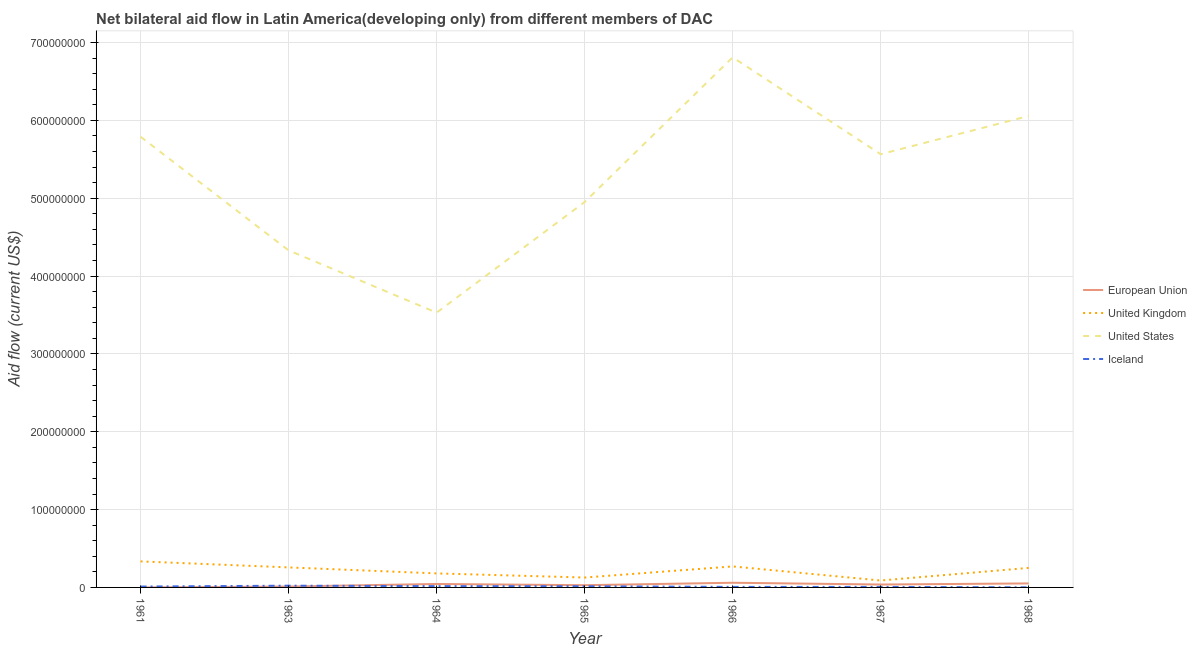How many different coloured lines are there?
Provide a short and direct response. 4. Is the number of lines equal to the number of legend labels?
Provide a short and direct response. Yes. What is the amount of aid given by us in 1965?
Provide a short and direct response. 4.95e+08. Across all years, what is the maximum amount of aid given by us?
Offer a terse response. 6.81e+08. Across all years, what is the minimum amount of aid given by uk?
Your answer should be very brief. 8.89e+06. In which year was the amount of aid given by us maximum?
Give a very brief answer. 1966. In which year was the amount of aid given by us minimum?
Provide a short and direct response. 1964. What is the total amount of aid given by iceland in the graph?
Your response must be concise. 8.05e+06. What is the difference between the amount of aid given by us in 1965 and that in 1968?
Offer a terse response. -1.11e+08. What is the difference between the amount of aid given by us in 1967 and the amount of aid given by eu in 1963?
Keep it short and to the point. 5.55e+08. What is the average amount of aid given by iceland per year?
Ensure brevity in your answer.  1.15e+06. In the year 1967, what is the difference between the amount of aid given by us and amount of aid given by uk?
Offer a terse response. 5.48e+08. In how many years, is the amount of aid given by iceland greater than 400000000 US$?
Your response must be concise. 0. What is the ratio of the amount of aid given by iceland in 1966 to that in 1967?
Offer a terse response. 1.03. Is the amount of aid given by eu in 1964 less than that in 1966?
Give a very brief answer. Yes. Is the difference between the amount of aid given by us in 1964 and 1966 greater than the difference between the amount of aid given by uk in 1964 and 1966?
Keep it short and to the point. No. What is the difference between the highest and the second highest amount of aid given by uk?
Keep it short and to the point. 6.46e+06. What is the difference between the highest and the lowest amount of aid given by us?
Keep it short and to the point. 3.28e+08. Is it the case that in every year, the sum of the amount of aid given by us and amount of aid given by eu is greater than the sum of amount of aid given by uk and amount of aid given by iceland?
Your answer should be compact. Yes. Does the amount of aid given by us monotonically increase over the years?
Keep it short and to the point. No. Is the amount of aid given by uk strictly greater than the amount of aid given by iceland over the years?
Provide a succinct answer. Yes. How many lines are there?
Your response must be concise. 4. What is the difference between two consecutive major ticks on the Y-axis?
Ensure brevity in your answer.  1.00e+08. Does the graph contain any zero values?
Your response must be concise. No. Does the graph contain grids?
Ensure brevity in your answer.  Yes. How many legend labels are there?
Offer a terse response. 4. What is the title of the graph?
Keep it short and to the point. Net bilateral aid flow in Latin America(developing only) from different members of DAC. What is the label or title of the Y-axis?
Your answer should be compact. Aid flow (current US$). What is the Aid flow (current US$) in European Union in 1961?
Offer a very short reply. 10000. What is the Aid flow (current US$) in United Kingdom in 1961?
Your answer should be compact. 3.34e+07. What is the Aid flow (current US$) in United States in 1961?
Your response must be concise. 5.79e+08. What is the Aid flow (current US$) of Iceland in 1961?
Your answer should be compact. 1.13e+06. What is the Aid flow (current US$) of European Union in 1963?
Provide a succinct answer. 1.14e+06. What is the Aid flow (current US$) in United Kingdom in 1963?
Your answer should be compact. 2.57e+07. What is the Aid flow (current US$) of United States in 1963?
Offer a very short reply. 4.33e+08. What is the Aid flow (current US$) in Iceland in 1963?
Keep it short and to the point. 2.23e+06. What is the Aid flow (current US$) of European Union in 1964?
Keep it short and to the point. 4.45e+06. What is the Aid flow (current US$) in United Kingdom in 1964?
Your answer should be compact. 1.80e+07. What is the Aid flow (current US$) in United States in 1964?
Your answer should be very brief. 3.53e+08. What is the Aid flow (current US$) of Iceland in 1964?
Offer a very short reply. 1.67e+06. What is the Aid flow (current US$) in European Union in 1965?
Your response must be concise. 2.85e+06. What is the Aid flow (current US$) of United Kingdom in 1965?
Your response must be concise. 1.27e+07. What is the Aid flow (current US$) of United States in 1965?
Your response must be concise. 4.95e+08. What is the Aid flow (current US$) in Iceland in 1965?
Provide a succinct answer. 1.53e+06. What is the Aid flow (current US$) of European Union in 1966?
Give a very brief answer. 6.01e+06. What is the Aid flow (current US$) in United Kingdom in 1966?
Provide a short and direct response. 2.70e+07. What is the Aid flow (current US$) in United States in 1966?
Make the answer very short. 6.81e+08. What is the Aid flow (current US$) in Iceland in 1966?
Give a very brief answer. 6.80e+05. What is the Aid flow (current US$) of European Union in 1967?
Provide a short and direct response. 3.73e+06. What is the Aid flow (current US$) of United Kingdom in 1967?
Ensure brevity in your answer.  8.89e+06. What is the Aid flow (current US$) in United States in 1967?
Provide a succinct answer. 5.57e+08. What is the Aid flow (current US$) in Iceland in 1967?
Your answer should be very brief. 6.60e+05. What is the Aid flow (current US$) in European Union in 1968?
Your answer should be compact. 5.15e+06. What is the Aid flow (current US$) in United Kingdom in 1968?
Give a very brief answer. 2.51e+07. What is the Aid flow (current US$) in United States in 1968?
Provide a short and direct response. 6.06e+08. Across all years, what is the maximum Aid flow (current US$) of European Union?
Keep it short and to the point. 6.01e+06. Across all years, what is the maximum Aid flow (current US$) in United Kingdom?
Offer a very short reply. 3.34e+07. Across all years, what is the maximum Aid flow (current US$) in United States?
Keep it short and to the point. 6.81e+08. Across all years, what is the maximum Aid flow (current US$) in Iceland?
Provide a short and direct response. 2.23e+06. Across all years, what is the minimum Aid flow (current US$) of European Union?
Make the answer very short. 10000. Across all years, what is the minimum Aid flow (current US$) in United Kingdom?
Make the answer very short. 8.89e+06. Across all years, what is the minimum Aid flow (current US$) of United States?
Keep it short and to the point. 3.53e+08. What is the total Aid flow (current US$) of European Union in the graph?
Your response must be concise. 2.33e+07. What is the total Aid flow (current US$) of United Kingdom in the graph?
Ensure brevity in your answer.  1.51e+08. What is the total Aid flow (current US$) of United States in the graph?
Your response must be concise. 3.70e+09. What is the total Aid flow (current US$) in Iceland in the graph?
Your answer should be very brief. 8.05e+06. What is the difference between the Aid flow (current US$) of European Union in 1961 and that in 1963?
Give a very brief answer. -1.13e+06. What is the difference between the Aid flow (current US$) of United Kingdom in 1961 and that in 1963?
Make the answer very short. 7.73e+06. What is the difference between the Aid flow (current US$) in United States in 1961 and that in 1963?
Provide a succinct answer. 1.46e+08. What is the difference between the Aid flow (current US$) in Iceland in 1961 and that in 1963?
Your response must be concise. -1.10e+06. What is the difference between the Aid flow (current US$) in European Union in 1961 and that in 1964?
Make the answer very short. -4.44e+06. What is the difference between the Aid flow (current US$) of United Kingdom in 1961 and that in 1964?
Your response must be concise. 1.54e+07. What is the difference between the Aid flow (current US$) in United States in 1961 and that in 1964?
Offer a terse response. 2.26e+08. What is the difference between the Aid flow (current US$) of Iceland in 1961 and that in 1964?
Offer a very short reply. -5.40e+05. What is the difference between the Aid flow (current US$) in European Union in 1961 and that in 1965?
Make the answer very short. -2.84e+06. What is the difference between the Aid flow (current US$) in United Kingdom in 1961 and that in 1965?
Provide a short and direct response. 2.07e+07. What is the difference between the Aid flow (current US$) in United States in 1961 and that in 1965?
Provide a succinct answer. 8.39e+07. What is the difference between the Aid flow (current US$) in Iceland in 1961 and that in 1965?
Ensure brevity in your answer.  -4.00e+05. What is the difference between the Aid flow (current US$) in European Union in 1961 and that in 1966?
Your answer should be compact. -6.00e+06. What is the difference between the Aid flow (current US$) in United Kingdom in 1961 and that in 1966?
Make the answer very short. 6.46e+06. What is the difference between the Aid flow (current US$) in United States in 1961 and that in 1966?
Your answer should be compact. -1.02e+08. What is the difference between the Aid flow (current US$) in Iceland in 1961 and that in 1966?
Give a very brief answer. 4.50e+05. What is the difference between the Aid flow (current US$) of European Union in 1961 and that in 1967?
Your answer should be compact. -3.72e+06. What is the difference between the Aid flow (current US$) of United Kingdom in 1961 and that in 1967?
Your response must be concise. 2.46e+07. What is the difference between the Aid flow (current US$) of United States in 1961 and that in 1967?
Your answer should be very brief. 2.25e+07. What is the difference between the Aid flow (current US$) of European Union in 1961 and that in 1968?
Offer a terse response. -5.14e+06. What is the difference between the Aid flow (current US$) in United Kingdom in 1961 and that in 1968?
Provide a short and direct response. 8.36e+06. What is the difference between the Aid flow (current US$) in United States in 1961 and that in 1968?
Make the answer very short. -2.67e+07. What is the difference between the Aid flow (current US$) of Iceland in 1961 and that in 1968?
Offer a terse response. 9.80e+05. What is the difference between the Aid flow (current US$) of European Union in 1963 and that in 1964?
Keep it short and to the point. -3.31e+06. What is the difference between the Aid flow (current US$) in United Kingdom in 1963 and that in 1964?
Your answer should be very brief. 7.70e+06. What is the difference between the Aid flow (current US$) of United States in 1963 and that in 1964?
Your response must be concise. 8.00e+07. What is the difference between the Aid flow (current US$) in Iceland in 1963 and that in 1964?
Keep it short and to the point. 5.60e+05. What is the difference between the Aid flow (current US$) in European Union in 1963 and that in 1965?
Provide a succinct answer. -1.71e+06. What is the difference between the Aid flow (current US$) in United Kingdom in 1963 and that in 1965?
Give a very brief answer. 1.30e+07. What is the difference between the Aid flow (current US$) of United States in 1963 and that in 1965?
Offer a very short reply. -6.21e+07. What is the difference between the Aid flow (current US$) in Iceland in 1963 and that in 1965?
Your response must be concise. 7.00e+05. What is the difference between the Aid flow (current US$) in European Union in 1963 and that in 1966?
Your answer should be very brief. -4.87e+06. What is the difference between the Aid flow (current US$) in United Kingdom in 1963 and that in 1966?
Offer a very short reply. -1.27e+06. What is the difference between the Aid flow (current US$) in United States in 1963 and that in 1966?
Make the answer very short. -2.48e+08. What is the difference between the Aid flow (current US$) in Iceland in 1963 and that in 1966?
Your answer should be compact. 1.55e+06. What is the difference between the Aid flow (current US$) of European Union in 1963 and that in 1967?
Keep it short and to the point. -2.59e+06. What is the difference between the Aid flow (current US$) in United Kingdom in 1963 and that in 1967?
Provide a succinct answer. 1.68e+07. What is the difference between the Aid flow (current US$) in United States in 1963 and that in 1967?
Your answer should be compact. -1.24e+08. What is the difference between the Aid flow (current US$) in Iceland in 1963 and that in 1967?
Your answer should be compact. 1.57e+06. What is the difference between the Aid flow (current US$) in European Union in 1963 and that in 1968?
Provide a succinct answer. -4.01e+06. What is the difference between the Aid flow (current US$) of United Kingdom in 1963 and that in 1968?
Offer a very short reply. 6.30e+05. What is the difference between the Aid flow (current US$) in United States in 1963 and that in 1968?
Ensure brevity in your answer.  -1.73e+08. What is the difference between the Aid flow (current US$) in Iceland in 1963 and that in 1968?
Your answer should be compact. 2.08e+06. What is the difference between the Aid flow (current US$) in European Union in 1964 and that in 1965?
Give a very brief answer. 1.60e+06. What is the difference between the Aid flow (current US$) in United Kingdom in 1964 and that in 1965?
Provide a short and direct response. 5.31e+06. What is the difference between the Aid flow (current US$) of United States in 1964 and that in 1965?
Provide a short and direct response. -1.42e+08. What is the difference between the Aid flow (current US$) of Iceland in 1964 and that in 1965?
Your response must be concise. 1.40e+05. What is the difference between the Aid flow (current US$) of European Union in 1964 and that in 1966?
Your response must be concise. -1.56e+06. What is the difference between the Aid flow (current US$) in United Kingdom in 1964 and that in 1966?
Keep it short and to the point. -8.97e+06. What is the difference between the Aid flow (current US$) in United States in 1964 and that in 1966?
Make the answer very short. -3.28e+08. What is the difference between the Aid flow (current US$) of Iceland in 1964 and that in 1966?
Your answer should be compact. 9.90e+05. What is the difference between the Aid flow (current US$) in European Union in 1964 and that in 1967?
Make the answer very short. 7.20e+05. What is the difference between the Aid flow (current US$) in United Kingdom in 1964 and that in 1967?
Provide a succinct answer. 9.13e+06. What is the difference between the Aid flow (current US$) in United States in 1964 and that in 1967?
Your answer should be compact. -2.04e+08. What is the difference between the Aid flow (current US$) in Iceland in 1964 and that in 1967?
Provide a succinct answer. 1.01e+06. What is the difference between the Aid flow (current US$) in European Union in 1964 and that in 1968?
Make the answer very short. -7.00e+05. What is the difference between the Aid flow (current US$) of United Kingdom in 1964 and that in 1968?
Your answer should be compact. -7.07e+06. What is the difference between the Aid flow (current US$) of United States in 1964 and that in 1968?
Your answer should be compact. -2.53e+08. What is the difference between the Aid flow (current US$) of Iceland in 1964 and that in 1968?
Provide a short and direct response. 1.52e+06. What is the difference between the Aid flow (current US$) of European Union in 1965 and that in 1966?
Ensure brevity in your answer.  -3.16e+06. What is the difference between the Aid flow (current US$) in United Kingdom in 1965 and that in 1966?
Offer a very short reply. -1.43e+07. What is the difference between the Aid flow (current US$) in United States in 1965 and that in 1966?
Offer a terse response. -1.86e+08. What is the difference between the Aid flow (current US$) in Iceland in 1965 and that in 1966?
Provide a short and direct response. 8.50e+05. What is the difference between the Aid flow (current US$) in European Union in 1965 and that in 1967?
Ensure brevity in your answer.  -8.80e+05. What is the difference between the Aid flow (current US$) of United Kingdom in 1965 and that in 1967?
Your answer should be very brief. 3.82e+06. What is the difference between the Aid flow (current US$) of United States in 1965 and that in 1967?
Offer a terse response. -6.14e+07. What is the difference between the Aid flow (current US$) in Iceland in 1965 and that in 1967?
Make the answer very short. 8.70e+05. What is the difference between the Aid flow (current US$) of European Union in 1965 and that in 1968?
Provide a short and direct response. -2.30e+06. What is the difference between the Aid flow (current US$) of United Kingdom in 1965 and that in 1968?
Your answer should be compact. -1.24e+07. What is the difference between the Aid flow (current US$) of United States in 1965 and that in 1968?
Make the answer very short. -1.11e+08. What is the difference between the Aid flow (current US$) in Iceland in 1965 and that in 1968?
Make the answer very short. 1.38e+06. What is the difference between the Aid flow (current US$) of European Union in 1966 and that in 1967?
Provide a short and direct response. 2.28e+06. What is the difference between the Aid flow (current US$) in United Kingdom in 1966 and that in 1967?
Keep it short and to the point. 1.81e+07. What is the difference between the Aid flow (current US$) in United States in 1966 and that in 1967?
Provide a short and direct response. 1.24e+08. What is the difference between the Aid flow (current US$) of European Union in 1966 and that in 1968?
Your answer should be compact. 8.60e+05. What is the difference between the Aid flow (current US$) in United Kingdom in 1966 and that in 1968?
Your response must be concise. 1.90e+06. What is the difference between the Aid flow (current US$) in United States in 1966 and that in 1968?
Offer a very short reply. 7.53e+07. What is the difference between the Aid flow (current US$) in Iceland in 1966 and that in 1968?
Make the answer very short. 5.30e+05. What is the difference between the Aid flow (current US$) of European Union in 1967 and that in 1968?
Give a very brief answer. -1.42e+06. What is the difference between the Aid flow (current US$) of United Kingdom in 1967 and that in 1968?
Give a very brief answer. -1.62e+07. What is the difference between the Aid flow (current US$) in United States in 1967 and that in 1968?
Make the answer very short. -4.92e+07. What is the difference between the Aid flow (current US$) in Iceland in 1967 and that in 1968?
Your response must be concise. 5.10e+05. What is the difference between the Aid flow (current US$) of European Union in 1961 and the Aid flow (current US$) of United Kingdom in 1963?
Your answer should be very brief. -2.57e+07. What is the difference between the Aid flow (current US$) of European Union in 1961 and the Aid flow (current US$) of United States in 1963?
Offer a terse response. -4.33e+08. What is the difference between the Aid flow (current US$) in European Union in 1961 and the Aid flow (current US$) in Iceland in 1963?
Give a very brief answer. -2.22e+06. What is the difference between the Aid flow (current US$) of United Kingdom in 1961 and the Aid flow (current US$) of United States in 1963?
Your answer should be very brief. -4.00e+08. What is the difference between the Aid flow (current US$) in United Kingdom in 1961 and the Aid flow (current US$) in Iceland in 1963?
Offer a terse response. 3.12e+07. What is the difference between the Aid flow (current US$) of United States in 1961 and the Aid flow (current US$) of Iceland in 1963?
Your answer should be very brief. 5.77e+08. What is the difference between the Aid flow (current US$) in European Union in 1961 and the Aid flow (current US$) in United Kingdom in 1964?
Your answer should be compact. -1.80e+07. What is the difference between the Aid flow (current US$) of European Union in 1961 and the Aid flow (current US$) of United States in 1964?
Make the answer very short. -3.53e+08. What is the difference between the Aid flow (current US$) of European Union in 1961 and the Aid flow (current US$) of Iceland in 1964?
Ensure brevity in your answer.  -1.66e+06. What is the difference between the Aid flow (current US$) in United Kingdom in 1961 and the Aid flow (current US$) in United States in 1964?
Give a very brief answer. -3.20e+08. What is the difference between the Aid flow (current US$) of United Kingdom in 1961 and the Aid flow (current US$) of Iceland in 1964?
Provide a short and direct response. 3.18e+07. What is the difference between the Aid flow (current US$) of United States in 1961 and the Aid flow (current US$) of Iceland in 1964?
Give a very brief answer. 5.77e+08. What is the difference between the Aid flow (current US$) in European Union in 1961 and the Aid flow (current US$) in United Kingdom in 1965?
Offer a very short reply. -1.27e+07. What is the difference between the Aid flow (current US$) of European Union in 1961 and the Aid flow (current US$) of United States in 1965?
Provide a succinct answer. -4.95e+08. What is the difference between the Aid flow (current US$) of European Union in 1961 and the Aid flow (current US$) of Iceland in 1965?
Make the answer very short. -1.52e+06. What is the difference between the Aid flow (current US$) in United Kingdom in 1961 and the Aid flow (current US$) in United States in 1965?
Provide a succinct answer. -4.62e+08. What is the difference between the Aid flow (current US$) of United Kingdom in 1961 and the Aid flow (current US$) of Iceland in 1965?
Provide a short and direct response. 3.19e+07. What is the difference between the Aid flow (current US$) in United States in 1961 and the Aid flow (current US$) in Iceland in 1965?
Give a very brief answer. 5.77e+08. What is the difference between the Aid flow (current US$) in European Union in 1961 and the Aid flow (current US$) in United Kingdom in 1966?
Your answer should be very brief. -2.70e+07. What is the difference between the Aid flow (current US$) in European Union in 1961 and the Aid flow (current US$) in United States in 1966?
Provide a short and direct response. -6.81e+08. What is the difference between the Aid flow (current US$) in European Union in 1961 and the Aid flow (current US$) in Iceland in 1966?
Your response must be concise. -6.70e+05. What is the difference between the Aid flow (current US$) in United Kingdom in 1961 and the Aid flow (current US$) in United States in 1966?
Keep it short and to the point. -6.48e+08. What is the difference between the Aid flow (current US$) in United Kingdom in 1961 and the Aid flow (current US$) in Iceland in 1966?
Offer a very short reply. 3.28e+07. What is the difference between the Aid flow (current US$) of United States in 1961 and the Aid flow (current US$) of Iceland in 1966?
Make the answer very short. 5.78e+08. What is the difference between the Aid flow (current US$) in European Union in 1961 and the Aid flow (current US$) in United Kingdom in 1967?
Provide a short and direct response. -8.88e+06. What is the difference between the Aid flow (current US$) in European Union in 1961 and the Aid flow (current US$) in United States in 1967?
Offer a very short reply. -5.57e+08. What is the difference between the Aid flow (current US$) of European Union in 1961 and the Aid flow (current US$) of Iceland in 1967?
Provide a succinct answer. -6.50e+05. What is the difference between the Aid flow (current US$) of United Kingdom in 1961 and the Aid flow (current US$) of United States in 1967?
Your response must be concise. -5.23e+08. What is the difference between the Aid flow (current US$) in United Kingdom in 1961 and the Aid flow (current US$) in Iceland in 1967?
Offer a very short reply. 3.28e+07. What is the difference between the Aid flow (current US$) in United States in 1961 and the Aid flow (current US$) in Iceland in 1967?
Provide a short and direct response. 5.78e+08. What is the difference between the Aid flow (current US$) of European Union in 1961 and the Aid flow (current US$) of United Kingdom in 1968?
Provide a succinct answer. -2.51e+07. What is the difference between the Aid flow (current US$) in European Union in 1961 and the Aid flow (current US$) in United States in 1968?
Offer a terse response. -6.06e+08. What is the difference between the Aid flow (current US$) of European Union in 1961 and the Aid flow (current US$) of Iceland in 1968?
Your answer should be compact. -1.40e+05. What is the difference between the Aid flow (current US$) of United Kingdom in 1961 and the Aid flow (current US$) of United States in 1968?
Keep it short and to the point. -5.72e+08. What is the difference between the Aid flow (current US$) of United Kingdom in 1961 and the Aid flow (current US$) of Iceland in 1968?
Your response must be concise. 3.33e+07. What is the difference between the Aid flow (current US$) of United States in 1961 and the Aid flow (current US$) of Iceland in 1968?
Your answer should be compact. 5.79e+08. What is the difference between the Aid flow (current US$) of European Union in 1963 and the Aid flow (current US$) of United Kingdom in 1964?
Your answer should be very brief. -1.69e+07. What is the difference between the Aid flow (current US$) of European Union in 1963 and the Aid flow (current US$) of United States in 1964?
Your response must be concise. -3.52e+08. What is the difference between the Aid flow (current US$) of European Union in 1963 and the Aid flow (current US$) of Iceland in 1964?
Offer a terse response. -5.30e+05. What is the difference between the Aid flow (current US$) of United Kingdom in 1963 and the Aid flow (current US$) of United States in 1964?
Keep it short and to the point. -3.27e+08. What is the difference between the Aid flow (current US$) of United Kingdom in 1963 and the Aid flow (current US$) of Iceland in 1964?
Provide a succinct answer. 2.40e+07. What is the difference between the Aid flow (current US$) of United States in 1963 and the Aid flow (current US$) of Iceland in 1964?
Ensure brevity in your answer.  4.31e+08. What is the difference between the Aid flow (current US$) of European Union in 1963 and the Aid flow (current US$) of United Kingdom in 1965?
Provide a succinct answer. -1.16e+07. What is the difference between the Aid flow (current US$) in European Union in 1963 and the Aid flow (current US$) in United States in 1965?
Give a very brief answer. -4.94e+08. What is the difference between the Aid flow (current US$) in European Union in 1963 and the Aid flow (current US$) in Iceland in 1965?
Offer a terse response. -3.90e+05. What is the difference between the Aid flow (current US$) in United Kingdom in 1963 and the Aid flow (current US$) in United States in 1965?
Your answer should be compact. -4.69e+08. What is the difference between the Aid flow (current US$) of United Kingdom in 1963 and the Aid flow (current US$) of Iceland in 1965?
Offer a terse response. 2.42e+07. What is the difference between the Aid flow (current US$) of United States in 1963 and the Aid flow (current US$) of Iceland in 1965?
Your response must be concise. 4.31e+08. What is the difference between the Aid flow (current US$) of European Union in 1963 and the Aid flow (current US$) of United Kingdom in 1966?
Provide a short and direct response. -2.58e+07. What is the difference between the Aid flow (current US$) of European Union in 1963 and the Aid flow (current US$) of United States in 1966?
Provide a short and direct response. -6.80e+08. What is the difference between the Aid flow (current US$) of United Kingdom in 1963 and the Aid flow (current US$) of United States in 1966?
Provide a succinct answer. -6.55e+08. What is the difference between the Aid flow (current US$) of United Kingdom in 1963 and the Aid flow (current US$) of Iceland in 1966?
Your answer should be very brief. 2.50e+07. What is the difference between the Aid flow (current US$) of United States in 1963 and the Aid flow (current US$) of Iceland in 1966?
Your answer should be very brief. 4.32e+08. What is the difference between the Aid flow (current US$) of European Union in 1963 and the Aid flow (current US$) of United Kingdom in 1967?
Offer a very short reply. -7.75e+06. What is the difference between the Aid flow (current US$) of European Union in 1963 and the Aid flow (current US$) of United States in 1967?
Make the answer very short. -5.55e+08. What is the difference between the Aid flow (current US$) in European Union in 1963 and the Aid flow (current US$) in Iceland in 1967?
Provide a short and direct response. 4.80e+05. What is the difference between the Aid flow (current US$) in United Kingdom in 1963 and the Aid flow (current US$) in United States in 1967?
Keep it short and to the point. -5.31e+08. What is the difference between the Aid flow (current US$) in United Kingdom in 1963 and the Aid flow (current US$) in Iceland in 1967?
Offer a terse response. 2.51e+07. What is the difference between the Aid flow (current US$) of United States in 1963 and the Aid flow (current US$) of Iceland in 1967?
Your response must be concise. 4.32e+08. What is the difference between the Aid flow (current US$) in European Union in 1963 and the Aid flow (current US$) in United Kingdom in 1968?
Provide a short and direct response. -2.40e+07. What is the difference between the Aid flow (current US$) in European Union in 1963 and the Aid flow (current US$) in United States in 1968?
Your response must be concise. -6.05e+08. What is the difference between the Aid flow (current US$) in European Union in 1963 and the Aid flow (current US$) in Iceland in 1968?
Provide a succinct answer. 9.90e+05. What is the difference between the Aid flow (current US$) in United Kingdom in 1963 and the Aid flow (current US$) in United States in 1968?
Your response must be concise. -5.80e+08. What is the difference between the Aid flow (current US$) in United Kingdom in 1963 and the Aid flow (current US$) in Iceland in 1968?
Make the answer very short. 2.56e+07. What is the difference between the Aid flow (current US$) in United States in 1963 and the Aid flow (current US$) in Iceland in 1968?
Ensure brevity in your answer.  4.33e+08. What is the difference between the Aid flow (current US$) in European Union in 1964 and the Aid flow (current US$) in United Kingdom in 1965?
Ensure brevity in your answer.  -8.26e+06. What is the difference between the Aid flow (current US$) of European Union in 1964 and the Aid flow (current US$) of United States in 1965?
Make the answer very short. -4.91e+08. What is the difference between the Aid flow (current US$) in European Union in 1964 and the Aid flow (current US$) in Iceland in 1965?
Provide a succinct answer. 2.92e+06. What is the difference between the Aid flow (current US$) in United Kingdom in 1964 and the Aid flow (current US$) in United States in 1965?
Your response must be concise. -4.77e+08. What is the difference between the Aid flow (current US$) of United Kingdom in 1964 and the Aid flow (current US$) of Iceland in 1965?
Make the answer very short. 1.65e+07. What is the difference between the Aid flow (current US$) in United States in 1964 and the Aid flow (current US$) in Iceland in 1965?
Ensure brevity in your answer.  3.51e+08. What is the difference between the Aid flow (current US$) in European Union in 1964 and the Aid flow (current US$) in United Kingdom in 1966?
Provide a short and direct response. -2.25e+07. What is the difference between the Aid flow (current US$) in European Union in 1964 and the Aid flow (current US$) in United States in 1966?
Offer a very short reply. -6.77e+08. What is the difference between the Aid flow (current US$) of European Union in 1964 and the Aid flow (current US$) of Iceland in 1966?
Make the answer very short. 3.77e+06. What is the difference between the Aid flow (current US$) in United Kingdom in 1964 and the Aid flow (current US$) in United States in 1966?
Provide a short and direct response. -6.63e+08. What is the difference between the Aid flow (current US$) of United Kingdom in 1964 and the Aid flow (current US$) of Iceland in 1966?
Provide a succinct answer. 1.73e+07. What is the difference between the Aid flow (current US$) of United States in 1964 and the Aid flow (current US$) of Iceland in 1966?
Offer a very short reply. 3.52e+08. What is the difference between the Aid flow (current US$) of European Union in 1964 and the Aid flow (current US$) of United Kingdom in 1967?
Provide a succinct answer. -4.44e+06. What is the difference between the Aid flow (current US$) of European Union in 1964 and the Aid flow (current US$) of United States in 1967?
Your answer should be very brief. -5.52e+08. What is the difference between the Aid flow (current US$) in European Union in 1964 and the Aid flow (current US$) in Iceland in 1967?
Keep it short and to the point. 3.79e+06. What is the difference between the Aid flow (current US$) in United Kingdom in 1964 and the Aid flow (current US$) in United States in 1967?
Make the answer very short. -5.39e+08. What is the difference between the Aid flow (current US$) of United Kingdom in 1964 and the Aid flow (current US$) of Iceland in 1967?
Ensure brevity in your answer.  1.74e+07. What is the difference between the Aid flow (current US$) in United States in 1964 and the Aid flow (current US$) in Iceland in 1967?
Offer a terse response. 3.52e+08. What is the difference between the Aid flow (current US$) of European Union in 1964 and the Aid flow (current US$) of United Kingdom in 1968?
Keep it short and to the point. -2.06e+07. What is the difference between the Aid flow (current US$) of European Union in 1964 and the Aid flow (current US$) of United States in 1968?
Give a very brief answer. -6.01e+08. What is the difference between the Aid flow (current US$) in European Union in 1964 and the Aid flow (current US$) in Iceland in 1968?
Provide a short and direct response. 4.30e+06. What is the difference between the Aid flow (current US$) of United Kingdom in 1964 and the Aid flow (current US$) of United States in 1968?
Your answer should be compact. -5.88e+08. What is the difference between the Aid flow (current US$) in United Kingdom in 1964 and the Aid flow (current US$) in Iceland in 1968?
Offer a very short reply. 1.79e+07. What is the difference between the Aid flow (current US$) of United States in 1964 and the Aid flow (current US$) of Iceland in 1968?
Your answer should be compact. 3.53e+08. What is the difference between the Aid flow (current US$) in European Union in 1965 and the Aid flow (current US$) in United Kingdom in 1966?
Make the answer very short. -2.41e+07. What is the difference between the Aid flow (current US$) of European Union in 1965 and the Aid flow (current US$) of United States in 1966?
Provide a succinct answer. -6.78e+08. What is the difference between the Aid flow (current US$) of European Union in 1965 and the Aid flow (current US$) of Iceland in 1966?
Give a very brief answer. 2.17e+06. What is the difference between the Aid flow (current US$) in United Kingdom in 1965 and the Aid flow (current US$) in United States in 1966?
Provide a short and direct response. -6.68e+08. What is the difference between the Aid flow (current US$) in United Kingdom in 1965 and the Aid flow (current US$) in Iceland in 1966?
Your response must be concise. 1.20e+07. What is the difference between the Aid flow (current US$) in United States in 1965 and the Aid flow (current US$) in Iceland in 1966?
Keep it short and to the point. 4.94e+08. What is the difference between the Aid flow (current US$) of European Union in 1965 and the Aid flow (current US$) of United Kingdom in 1967?
Provide a succinct answer. -6.04e+06. What is the difference between the Aid flow (current US$) in European Union in 1965 and the Aid flow (current US$) in United States in 1967?
Your answer should be very brief. -5.54e+08. What is the difference between the Aid flow (current US$) of European Union in 1965 and the Aid flow (current US$) of Iceland in 1967?
Offer a very short reply. 2.19e+06. What is the difference between the Aid flow (current US$) of United Kingdom in 1965 and the Aid flow (current US$) of United States in 1967?
Provide a short and direct response. -5.44e+08. What is the difference between the Aid flow (current US$) of United Kingdom in 1965 and the Aid flow (current US$) of Iceland in 1967?
Ensure brevity in your answer.  1.20e+07. What is the difference between the Aid flow (current US$) of United States in 1965 and the Aid flow (current US$) of Iceland in 1967?
Provide a short and direct response. 4.94e+08. What is the difference between the Aid flow (current US$) in European Union in 1965 and the Aid flow (current US$) in United Kingdom in 1968?
Give a very brief answer. -2.22e+07. What is the difference between the Aid flow (current US$) of European Union in 1965 and the Aid flow (current US$) of United States in 1968?
Give a very brief answer. -6.03e+08. What is the difference between the Aid flow (current US$) of European Union in 1965 and the Aid flow (current US$) of Iceland in 1968?
Give a very brief answer. 2.70e+06. What is the difference between the Aid flow (current US$) in United Kingdom in 1965 and the Aid flow (current US$) in United States in 1968?
Offer a very short reply. -5.93e+08. What is the difference between the Aid flow (current US$) of United Kingdom in 1965 and the Aid flow (current US$) of Iceland in 1968?
Offer a terse response. 1.26e+07. What is the difference between the Aid flow (current US$) in United States in 1965 and the Aid flow (current US$) in Iceland in 1968?
Offer a terse response. 4.95e+08. What is the difference between the Aid flow (current US$) of European Union in 1966 and the Aid flow (current US$) of United Kingdom in 1967?
Give a very brief answer. -2.88e+06. What is the difference between the Aid flow (current US$) of European Union in 1966 and the Aid flow (current US$) of United States in 1967?
Provide a succinct answer. -5.51e+08. What is the difference between the Aid flow (current US$) in European Union in 1966 and the Aid flow (current US$) in Iceland in 1967?
Provide a succinct answer. 5.35e+06. What is the difference between the Aid flow (current US$) of United Kingdom in 1966 and the Aid flow (current US$) of United States in 1967?
Offer a terse response. -5.30e+08. What is the difference between the Aid flow (current US$) of United Kingdom in 1966 and the Aid flow (current US$) of Iceland in 1967?
Your response must be concise. 2.63e+07. What is the difference between the Aid flow (current US$) in United States in 1966 and the Aid flow (current US$) in Iceland in 1967?
Provide a short and direct response. 6.80e+08. What is the difference between the Aid flow (current US$) of European Union in 1966 and the Aid flow (current US$) of United Kingdom in 1968?
Offer a very short reply. -1.91e+07. What is the difference between the Aid flow (current US$) in European Union in 1966 and the Aid flow (current US$) in United States in 1968?
Provide a short and direct response. -6.00e+08. What is the difference between the Aid flow (current US$) of European Union in 1966 and the Aid flow (current US$) of Iceland in 1968?
Offer a very short reply. 5.86e+06. What is the difference between the Aid flow (current US$) in United Kingdom in 1966 and the Aid flow (current US$) in United States in 1968?
Provide a succinct answer. -5.79e+08. What is the difference between the Aid flow (current US$) in United Kingdom in 1966 and the Aid flow (current US$) in Iceland in 1968?
Offer a terse response. 2.68e+07. What is the difference between the Aid flow (current US$) of United States in 1966 and the Aid flow (current US$) of Iceland in 1968?
Your answer should be very brief. 6.81e+08. What is the difference between the Aid flow (current US$) in European Union in 1967 and the Aid flow (current US$) in United Kingdom in 1968?
Provide a succinct answer. -2.14e+07. What is the difference between the Aid flow (current US$) in European Union in 1967 and the Aid flow (current US$) in United States in 1968?
Provide a short and direct response. -6.02e+08. What is the difference between the Aid flow (current US$) of European Union in 1967 and the Aid flow (current US$) of Iceland in 1968?
Offer a very short reply. 3.58e+06. What is the difference between the Aid flow (current US$) of United Kingdom in 1967 and the Aid flow (current US$) of United States in 1968?
Ensure brevity in your answer.  -5.97e+08. What is the difference between the Aid flow (current US$) in United Kingdom in 1967 and the Aid flow (current US$) in Iceland in 1968?
Give a very brief answer. 8.74e+06. What is the difference between the Aid flow (current US$) in United States in 1967 and the Aid flow (current US$) in Iceland in 1968?
Your response must be concise. 5.56e+08. What is the average Aid flow (current US$) of European Union per year?
Ensure brevity in your answer.  3.33e+06. What is the average Aid flow (current US$) in United Kingdom per year?
Your answer should be very brief. 2.16e+07. What is the average Aid flow (current US$) of United States per year?
Provide a short and direct response. 5.29e+08. What is the average Aid flow (current US$) in Iceland per year?
Provide a succinct answer. 1.15e+06. In the year 1961, what is the difference between the Aid flow (current US$) of European Union and Aid flow (current US$) of United Kingdom?
Keep it short and to the point. -3.34e+07. In the year 1961, what is the difference between the Aid flow (current US$) of European Union and Aid flow (current US$) of United States?
Give a very brief answer. -5.79e+08. In the year 1961, what is the difference between the Aid flow (current US$) of European Union and Aid flow (current US$) of Iceland?
Offer a very short reply. -1.12e+06. In the year 1961, what is the difference between the Aid flow (current US$) in United Kingdom and Aid flow (current US$) in United States?
Make the answer very short. -5.46e+08. In the year 1961, what is the difference between the Aid flow (current US$) in United Kingdom and Aid flow (current US$) in Iceland?
Offer a terse response. 3.23e+07. In the year 1961, what is the difference between the Aid flow (current US$) in United States and Aid flow (current US$) in Iceland?
Your answer should be compact. 5.78e+08. In the year 1963, what is the difference between the Aid flow (current US$) in European Union and Aid flow (current US$) in United Kingdom?
Provide a succinct answer. -2.46e+07. In the year 1963, what is the difference between the Aid flow (current US$) of European Union and Aid flow (current US$) of United States?
Provide a short and direct response. -4.32e+08. In the year 1963, what is the difference between the Aid flow (current US$) in European Union and Aid flow (current US$) in Iceland?
Your response must be concise. -1.09e+06. In the year 1963, what is the difference between the Aid flow (current US$) in United Kingdom and Aid flow (current US$) in United States?
Your answer should be very brief. -4.07e+08. In the year 1963, what is the difference between the Aid flow (current US$) of United Kingdom and Aid flow (current US$) of Iceland?
Provide a short and direct response. 2.35e+07. In the year 1963, what is the difference between the Aid flow (current US$) in United States and Aid flow (current US$) in Iceland?
Your response must be concise. 4.31e+08. In the year 1964, what is the difference between the Aid flow (current US$) in European Union and Aid flow (current US$) in United Kingdom?
Offer a terse response. -1.36e+07. In the year 1964, what is the difference between the Aid flow (current US$) in European Union and Aid flow (current US$) in United States?
Offer a very short reply. -3.49e+08. In the year 1964, what is the difference between the Aid flow (current US$) in European Union and Aid flow (current US$) in Iceland?
Provide a succinct answer. 2.78e+06. In the year 1964, what is the difference between the Aid flow (current US$) of United Kingdom and Aid flow (current US$) of United States?
Offer a very short reply. -3.35e+08. In the year 1964, what is the difference between the Aid flow (current US$) in United Kingdom and Aid flow (current US$) in Iceland?
Provide a succinct answer. 1.64e+07. In the year 1964, what is the difference between the Aid flow (current US$) in United States and Aid flow (current US$) in Iceland?
Your response must be concise. 3.51e+08. In the year 1965, what is the difference between the Aid flow (current US$) of European Union and Aid flow (current US$) of United Kingdom?
Give a very brief answer. -9.86e+06. In the year 1965, what is the difference between the Aid flow (current US$) of European Union and Aid flow (current US$) of United States?
Your response must be concise. -4.92e+08. In the year 1965, what is the difference between the Aid flow (current US$) in European Union and Aid flow (current US$) in Iceland?
Keep it short and to the point. 1.32e+06. In the year 1965, what is the difference between the Aid flow (current US$) in United Kingdom and Aid flow (current US$) in United States?
Offer a terse response. -4.82e+08. In the year 1965, what is the difference between the Aid flow (current US$) in United Kingdom and Aid flow (current US$) in Iceland?
Provide a short and direct response. 1.12e+07. In the year 1965, what is the difference between the Aid flow (current US$) of United States and Aid flow (current US$) of Iceland?
Make the answer very short. 4.94e+08. In the year 1966, what is the difference between the Aid flow (current US$) in European Union and Aid flow (current US$) in United Kingdom?
Offer a very short reply. -2.10e+07. In the year 1966, what is the difference between the Aid flow (current US$) in European Union and Aid flow (current US$) in United States?
Your response must be concise. -6.75e+08. In the year 1966, what is the difference between the Aid flow (current US$) of European Union and Aid flow (current US$) of Iceland?
Your response must be concise. 5.33e+06. In the year 1966, what is the difference between the Aid flow (current US$) of United Kingdom and Aid flow (current US$) of United States?
Offer a very short reply. -6.54e+08. In the year 1966, what is the difference between the Aid flow (current US$) in United Kingdom and Aid flow (current US$) in Iceland?
Offer a very short reply. 2.63e+07. In the year 1966, what is the difference between the Aid flow (current US$) of United States and Aid flow (current US$) of Iceland?
Ensure brevity in your answer.  6.80e+08. In the year 1967, what is the difference between the Aid flow (current US$) of European Union and Aid flow (current US$) of United Kingdom?
Provide a succinct answer. -5.16e+06. In the year 1967, what is the difference between the Aid flow (current US$) in European Union and Aid flow (current US$) in United States?
Provide a short and direct response. -5.53e+08. In the year 1967, what is the difference between the Aid flow (current US$) of European Union and Aid flow (current US$) of Iceland?
Offer a terse response. 3.07e+06. In the year 1967, what is the difference between the Aid flow (current US$) in United Kingdom and Aid flow (current US$) in United States?
Ensure brevity in your answer.  -5.48e+08. In the year 1967, what is the difference between the Aid flow (current US$) in United Kingdom and Aid flow (current US$) in Iceland?
Provide a succinct answer. 8.23e+06. In the year 1967, what is the difference between the Aid flow (current US$) of United States and Aid flow (current US$) of Iceland?
Make the answer very short. 5.56e+08. In the year 1968, what is the difference between the Aid flow (current US$) in European Union and Aid flow (current US$) in United Kingdom?
Provide a succinct answer. -1.99e+07. In the year 1968, what is the difference between the Aid flow (current US$) in European Union and Aid flow (current US$) in United States?
Your response must be concise. -6.01e+08. In the year 1968, what is the difference between the Aid flow (current US$) in United Kingdom and Aid flow (current US$) in United States?
Give a very brief answer. -5.81e+08. In the year 1968, what is the difference between the Aid flow (current US$) in United Kingdom and Aid flow (current US$) in Iceland?
Offer a terse response. 2.49e+07. In the year 1968, what is the difference between the Aid flow (current US$) of United States and Aid flow (current US$) of Iceland?
Offer a very short reply. 6.06e+08. What is the ratio of the Aid flow (current US$) of European Union in 1961 to that in 1963?
Make the answer very short. 0.01. What is the ratio of the Aid flow (current US$) in United Kingdom in 1961 to that in 1963?
Give a very brief answer. 1.3. What is the ratio of the Aid flow (current US$) of United States in 1961 to that in 1963?
Keep it short and to the point. 1.34. What is the ratio of the Aid flow (current US$) in Iceland in 1961 to that in 1963?
Ensure brevity in your answer.  0.51. What is the ratio of the Aid flow (current US$) of European Union in 1961 to that in 1964?
Your response must be concise. 0. What is the ratio of the Aid flow (current US$) in United Kingdom in 1961 to that in 1964?
Your answer should be very brief. 1.86. What is the ratio of the Aid flow (current US$) of United States in 1961 to that in 1964?
Keep it short and to the point. 1.64. What is the ratio of the Aid flow (current US$) in Iceland in 1961 to that in 1964?
Your answer should be very brief. 0.68. What is the ratio of the Aid flow (current US$) of European Union in 1961 to that in 1965?
Your answer should be compact. 0. What is the ratio of the Aid flow (current US$) in United Kingdom in 1961 to that in 1965?
Ensure brevity in your answer.  2.63. What is the ratio of the Aid flow (current US$) in United States in 1961 to that in 1965?
Your response must be concise. 1.17. What is the ratio of the Aid flow (current US$) in Iceland in 1961 to that in 1965?
Give a very brief answer. 0.74. What is the ratio of the Aid flow (current US$) in European Union in 1961 to that in 1966?
Your answer should be very brief. 0. What is the ratio of the Aid flow (current US$) of United Kingdom in 1961 to that in 1966?
Your answer should be very brief. 1.24. What is the ratio of the Aid flow (current US$) in United States in 1961 to that in 1966?
Provide a succinct answer. 0.85. What is the ratio of the Aid flow (current US$) of Iceland in 1961 to that in 1966?
Keep it short and to the point. 1.66. What is the ratio of the Aid flow (current US$) of European Union in 1961 to that in 1967?
Offer a very short reply. 0. What is the ratio of the Aid flow (current US$) of United Kingdom in 1961 to that in 1967?
Provide a short and direct response. 3.76. What is the ratio of the Aid flow (current US$) in United States in 1961 to that in 1967?
Offer a terse response. 1.04. What is the ratio of the Aid flow (current US$) of Iceland in 1961 to that in 1967?
Offer a terse response. 1.71. What is the ratio of the Aid flow (current US$) of European Union in 1961 to that in 1968?
Your answer should be very brief. 0. What is the ratio of the Aid flow (current US$) in United Kingdom in 1961 to that in 1968?
Your answer should be very brief. 1.33. What is the ratio of the Aid flow (current US$) in United States in 1961 to that in 1968?
Give a very brief answer. 0.96. What is the ratio of the Aid flow (current US$) in Iceland in 1961 to that in 1968?
Offer a terse response. 7.53. What is the ratio of the Aid flow (current US$) in European Union in 1963 to that in 1964?
Your answer should be very brief. 0.26. What is the ratio of the Aid flow (current US$) in United Kingdom in 1963 to that in 1964?
Your response must be concise. 1.43. What is the ratio of the Aid flow (current US$) in United States in 1963 to that in 1964?
Offer a terse response. 1.23. What is the ratio of the Aid flow (current US$) of Iceland in 1963 to that in 1964?
Your response must be concise. 1.34. What is the ratio of the Aid flow (current US$) in European Union in 1963 to that in 1965?
Your response must be concise. 0.4. What is the ratio of the Aid flow (current US$) in United Kingdom in 1963 to that in 1965?
Keep it short and to the point. 2.02. What is the ratio of the Aid flow (current US$) in United States in 1963 to that in 1965?
Make the answer very short. 0.87. What is the ratio of the Aid flow (current US$) of Iceland in 1963 to that in 1965?
Provide a short and direct response. 1.46. What is the ratio of the Aid flow (current US$) in European Union in 1963 to that in 1966?
Ensure brevity in your answer.  0.19. What is the ratio of the Aid flow (current US$) in United Kingdom in 1963 to that in 1966?
Offer a terse response. 0.95. What is the ratio of the Aid flow (current US$) in United States in 1963 to that in 1966?
Provide a succinct answer. 0.64. What is the ratio of the Aid flow (current US$) in Iceland in 1963 to that in 1966?
Provide a short and direct response. 3.28. What is the ratio of the Aid flow (current US$) of European Union in 1963 to that in 1967?
Offer a terse response. 0.31. What is the ratio of the Aid flow (current US$) of United Kingdom in 1963 to that in 1967?
Offer a very short reply. 2.89. What is the ratio of the Aid flow (current US$) of United States in 1963 to that in 1967?
Give a very brief answer. 0.78. What is the ratio of the Aid flow (current US$) in Iceland in 1963 to that in 1967?
Your answer should be very brief. 3.38. What is the ratio of the Aid flow (current US$) in European Union in 1963 to that in 1968?
Provide a succinct answer. 0.22. What is the ratio of the Aid flow (current US$) in United Kingdom in 1963 to that in 1968?
Offer a terse response. 1.03. What is the ratio of the Aid flow (current US$) in United States in 1963 to that in 1968?
Your answer should be very brief. 0.71. What is the ratio of the Aid flow (current US$) of Iceland in 1963 to that in 1968?
Make the answer very short. 14.87. What is the ratio of the Aid flow (current US$) in European Union in 1964 to that in 1965?
Make the answer very short. 1.56. What is the ratio of the Aid flow (current US$) in United Kingdom in 1964 to that in 1965?
Provide a short and direct response. 1.42. What is the ratio of the Aid flow (current US$) in United States in 1964 to that in 1965?
Provide a succinct answer. 0.71. What is the ratio of the Aid flow (current US$) in Iceland in 1964 to that in 1965?
Ensure brevity in your answer.  1.09. What is the ratio of the Aid flow (current US$) in European Union in 1964 to that in 1966?
Provide a succinct answer. 0.74. What is the ratio of the Aid flow (current US$) of United Kingdom in 1964 to that in 1966?
Ensure brevity in your answer.  0.67. What is the ratio of the Aid flow (current US$) in United States in 1964 to that in 1966?
Offer a very short reply. 0.52. What is the ratio of the Aid flow (current US$) of Iceland in 1964 to that in 1966?
Keep it short and to the point. 2.46. What is the ratio of the Aid flow (current US$) of European Union in 1964 to that in 1967?
Offer a very short reply. 1.19. What is the ratio of the Aid flow (current US$) of United Kingdom in 1964 to that in 1967?
Your answer should be very brief. 2.03. What is the ratio of the Aid flow (current US$) of United States in 1964 to that in 1967?
Your answer should be compact. 0.63. What is the ratio of the Aid flow (current US$) of Iceland in 1964 to that in 1967?
Your response must be concise. 2.53. What is the ratio of the Aid flow (current US$) of European Union in 1964 to that in 1968?
Give a very brief answer. 0.86. What is the ratio of the Aid flow (current US$) in United Kingdom in 1964 to that in 1968?
Make the answer very short. 0.72. What is the ratio of the Aid flow (current US$) in United States in 1964 to that in 1968?
Provide a succinct answer. 0.58. What is the ratio of the Aid flow (current US$) in Iceland in 1964 to that in 1968?
Your answer should be very brief. 11.13. What is the ratio of the Aid flow (current US$) of European Union in 1965 to that in 1966?
Your answer should be very brief. 0.47. What is the ratio of the Aid flow (current US$) in United Kingdom in 1965 to that in 1966?
Provide a short and direct response. 0.47. What is the ratio of the Aid flow (current US$) of United States in 1965 to that in 1966?
Provide a short and direct response. 0.73. What is the ratio of the Aid flow (current US$) of Iceland in 1965 to that in 1966?
Ensure brevity in your answer.  2.25. What is the ratio of the Aid flow (current US$) in European Union in 1965 to that in 1967?
Ensure brevity in your answer.  0.76. What is the ratio of the Aid flow (current US$) in United Kingdom in 1965 to that in 1967?
Offer a terse response. 1.43. What is the ratio of the Aid flow (current US$) in United States in 1965 to that in 1967?
Provide a succinct answer. 0.89. What is the ratio of the Aid flow (current US$) of Iceland in 1965 to that in 1967?
Provide a succinct answer. 2.32. What is the ratio of the Aid flow (current US$) of European Union in 1965 to that in 1968?
Your response must be concise. 0.55. What is the ratio of the Aid flow (current US$) of United Kingdom in 1965 to that in 1968?
Make the answer very short. 0.51. What is the ratio of the Aid flow (current US$) in United States in 1965 to that in 1968?
Provide a succinct answer. 0.82. What is the ratio of the Aid flow (current US$) in Iceland in 1965 to that in 1968?
Offer a very short reply. 10.2. What is the ratio of the Aid flow (current US$) of European Union in 1966 to that in 1967?
Make the answer very short. 1.61. What is the ratio of the Aid flow (current US$) in United Kingdom in 1966 to that in 1967?
Give a very brief answer. 3.04. What is the ratio of the Aid flow (current US$) in United States in 1966 to that in 1967?
Your response must be concise. 1.22. What is the ratio of the Aid flow (current US$) in Iceland in 1966 to that in 1967?
Make the answer very short. 1.03. What is the ratio of the Aid flow (current US$) in European Union in 1966 to that in 1968?
Your response must be concise. 1.17. What is the ratio of the Aid flow (current US$) in United Kingdom in 1966 to that in 1968?
Your answer should be very brief. 1.08. What is the ratio of the Aid flow (current US$) of United States in 1966 to that in 1968?
Offer a very short reply. 1.12. What is the ratio of the Aid flow (current US$) of Iceland in 1966 to that in 1968?
Provide a succinct answer. 4.53. What is the ratio of the Aid flow (current US$) of European Union in 1967 to that in 1968?
Offer a very short reply. 0.72. What is the ratio of the Aid flow (current US$) of United Kingdom in 1967 to that in 1968?
Make the answer very short. 0.35. What is the ratio of the Aid flow (current US$) in United States in 1967 to that in 1968?
Provide a short and direct response. 0.92. What is the difference between the highest and the second highest Aid flow (current US$) in European Union?
Your answer should be very brief. 8.60e+05. What is the difference between the highest and the second highest Aid flow (current US$) of United Kingdom?
Your answer should be compact. 6.46e+06. What is the difference between the highest and the second highest Aid flow (current US$) of United States?
Ensure brevity in your answer.  7.53e+07. What is the difference between the highest and the second highest Aid flow (current US$) of Iceland?
Ensure brevity in your answer.  5.60e+05. What is the difference between the highest and the lowest Aid flow (current US$) of United Kingdom?
Make the answer very short. 2.46e+07. What is the difference between the highest and the lowest Aid flow (current US$) of United States?
Ensure brevity in your answer.  3.28e+08. What is the difference between the highest and the lowest Aid flow (current US$) in Iceland?
Keep it short and to the point. 2.08e+06. 